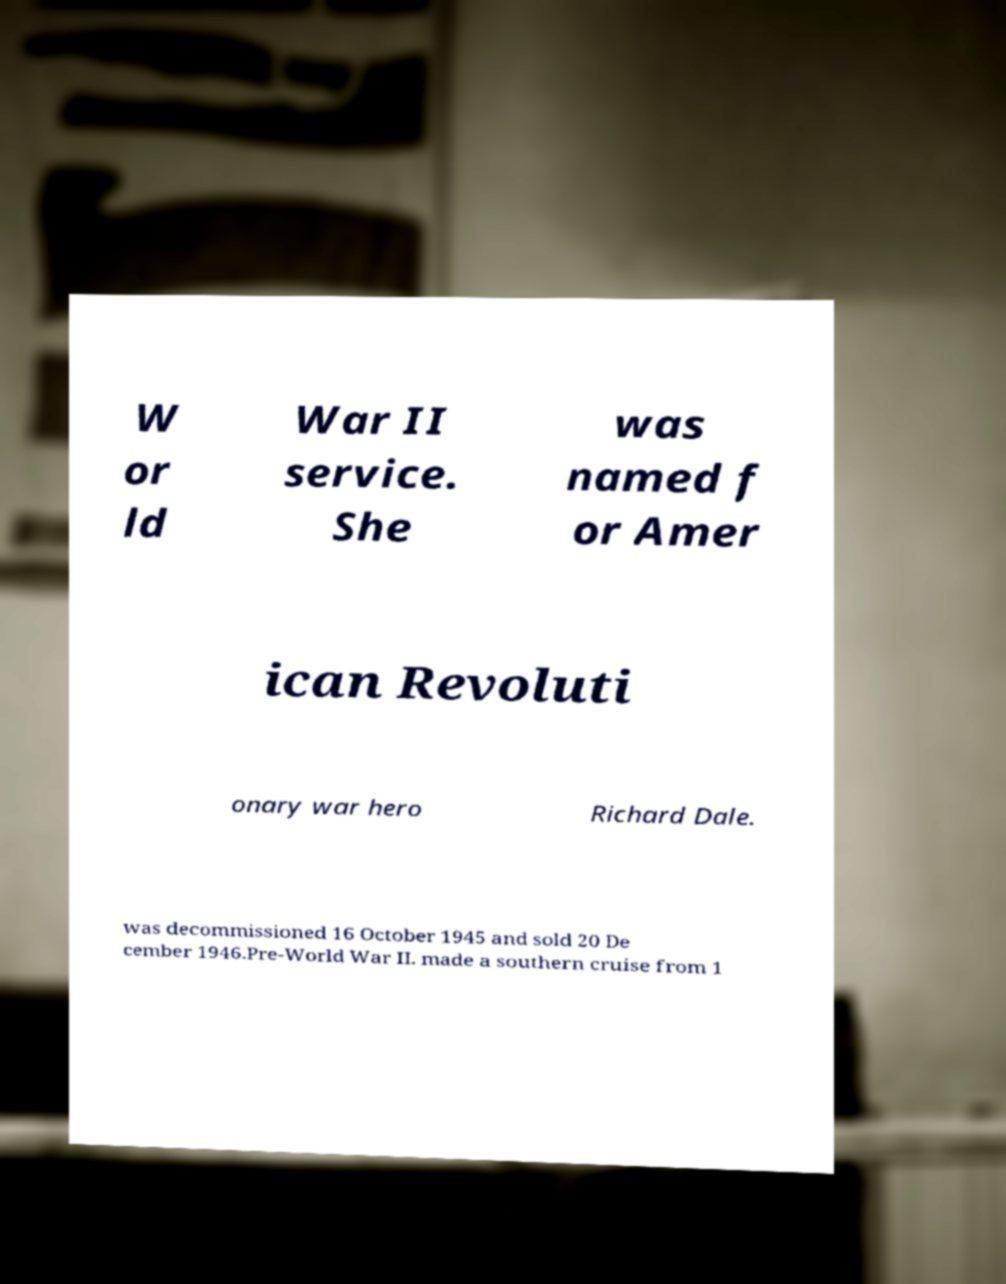Can you read and provide the text displayed in the image?This photo seems to have some interesting text. Can you extract and type it out for me? W or ld War II service. She was named f or Amer ican Revoluti onary war hero Richard Dale. was decommissioned 16 October 1945 and sold 20 De cember 1946.Pre-World War II. made a southern cruise from 1 